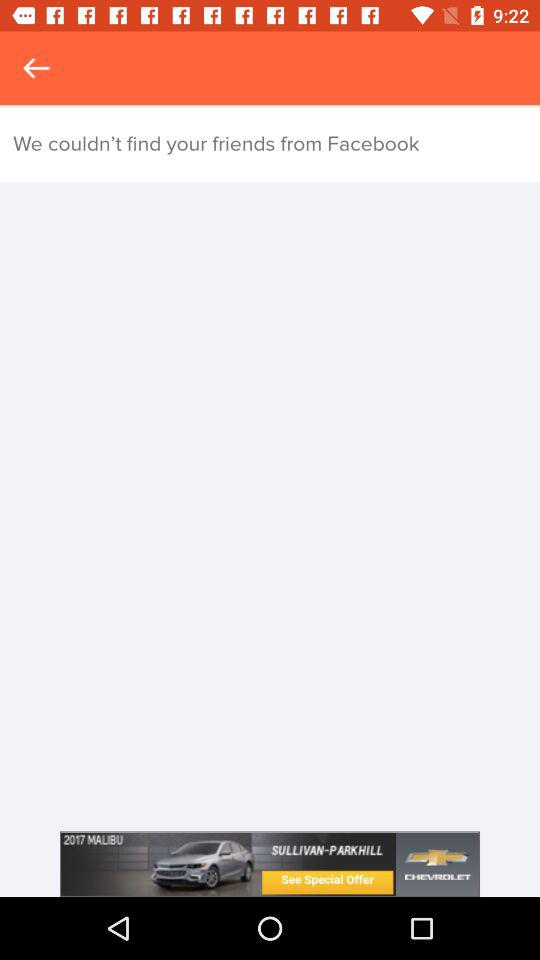How many friends are found?
When the provided information is insufficient, respond with <no answer>. <no answer> 